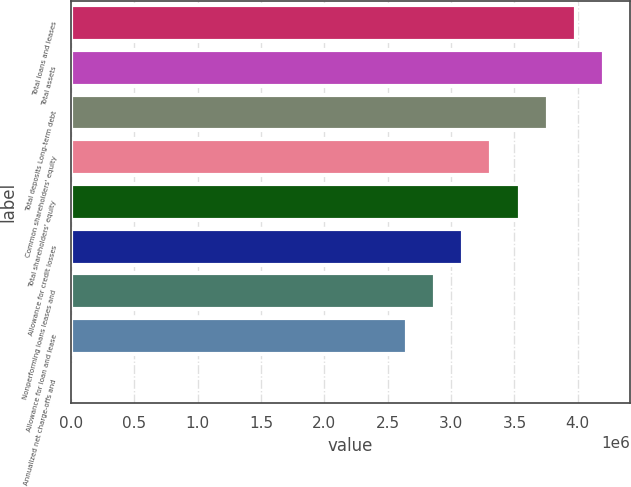<chart> <loc_0><loc_0><loc_500><loc_500><bar_chart><fcel>Total loans and leases<fcel>Total assets<fcel>Total deposits Long-term debt<fcel>Common shareholders' equity<fcel>Total shareholders' equity<fcel>Allowance for credit losses<fcel>Nonperforming loans leases and<fcel>Allowance for loan and lease<fcel>Annualized net charge-offs and<nl><fcel>3.98237e+06<fcel>4.20362e+06<fcel>3.76113e+06<fcel>3.31864e+06<fcel>3.53989e+06<fcel>3.0974e+06<fcel>2.87616e+06<fcel>2.65492e+06<fcel>1.52<nl></chart> 